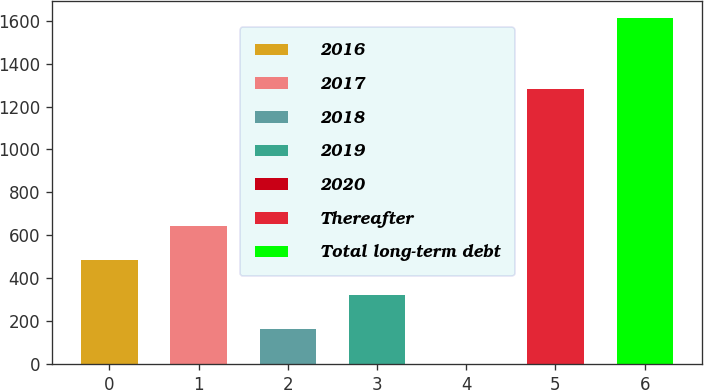<chart> <loc_0><loc_0><loc_500><loc_500><bar_chart><fcel>2016<fcel>2017<fcel>2018<fcel>2019<fcel>2020<fcel>Thereafter<fcel>Total long-term debt<nl><fcel>484.29<fcel>645.42<fcel>162.03<fcel>323.16<fcel>0.9<fcel>1282.5<fcel>1612.2<nl></chart> 